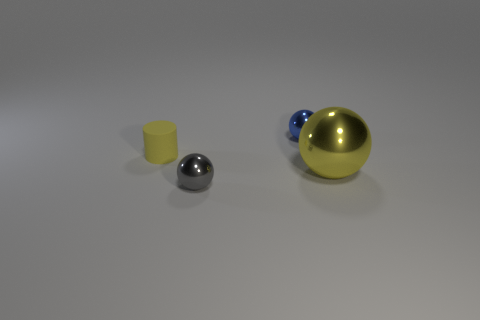Subtract all tiny balls. How many balls are left? 1 Add 3 tiny things. How many objects exist? 7 Subtract all gray balls. How many balls are left? 2 Subtract 1 spheres. How many spheres are left? 2 Subtract all spheres. How many objects are left? 1 Subtract 0 cyan blocks. How many objects are left? 4 Subtract all blue balls. Subtract all red cylinders. How many balls are left? 2 Subtract all purple blocks. Subtract all small metallic objects. How many objects are left? 2 Add 1 large spheres. How many large spheres are left? 2 Add 2 blue metal spheres. How many blue metal spheres exist? 3 